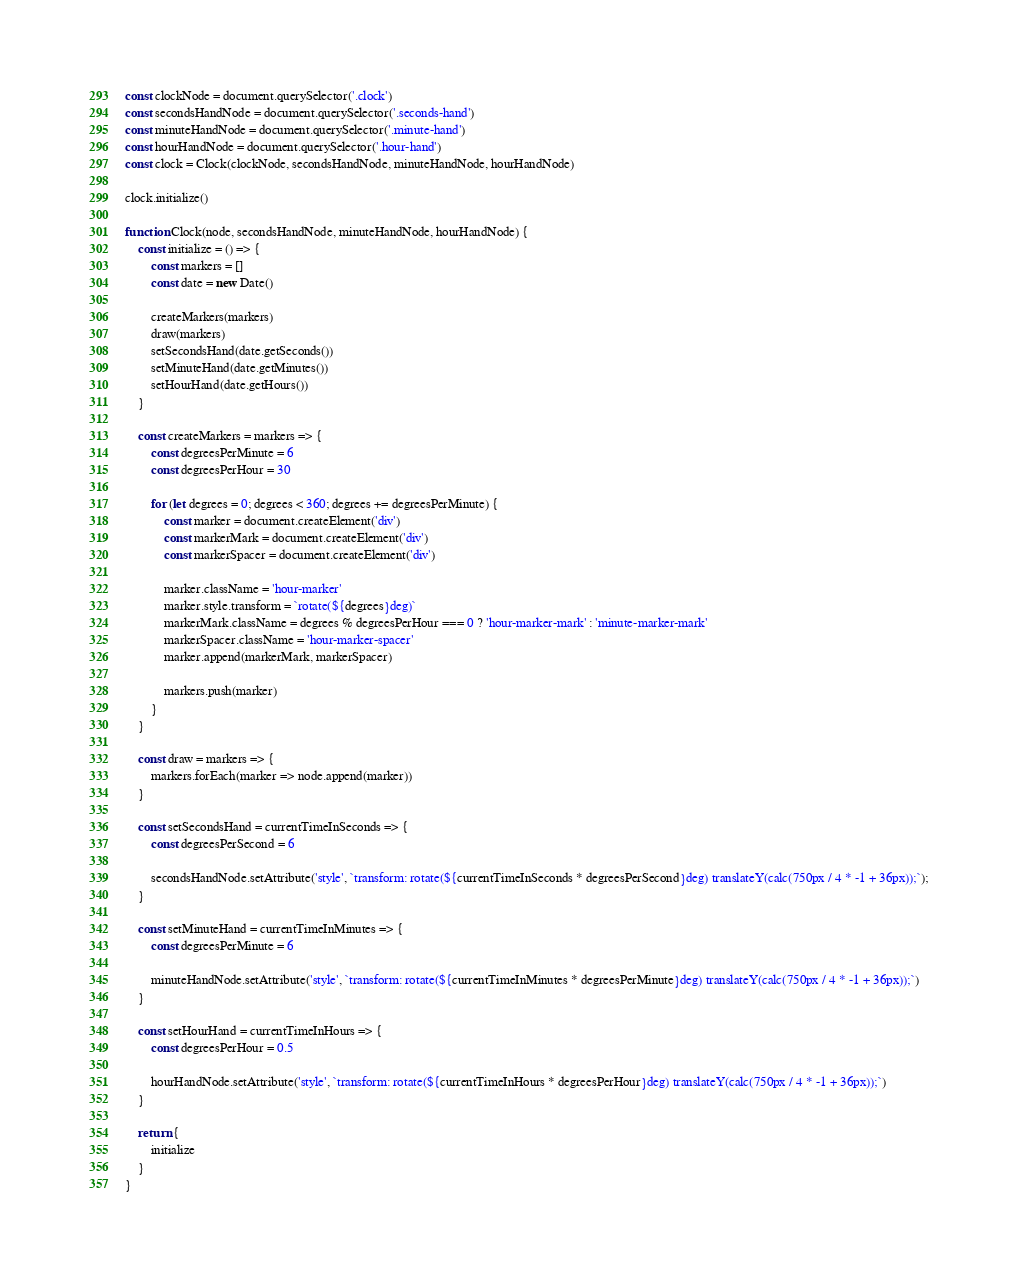<code> <loc_0><loc_0><loc_500><loc_500><_JavaScript_>const clockNode = document.querySelector('.clock')
const secondsHandNode = document.querySelector('.seconds-hand')
const minuteHandNode = document.querySelector('.minute-hand')
const hourHandNode = document.querySelector('.hour-hand')
const clock = Clock(clockNode, secondsHandNode, minuteHandNode, hourHandNode)

clock.initialize()

function Clock(node, secondsHandNode, minuteHandNode, hourHandNode) {
    const initialize = () => {
        const markers = []
        const date = new Date()

        createMarkers(markers)
        draw(markers)
        setSecondsHand(date.getSeconds())
        setMinuteHand(date.getMinutes())
        setHourHand(date.getHours())
    }

    const createMarkers = markers => {
        const degreesPerMinute = 6
        const degreesPerHour = 30

        for (let degrees = 0; degrees < 360; degrees += degreesPerMinute) {
            const marker = document.createElement('div')
            const markerMark = document.createElement('div')
            const markerSpacer = document.createElement('div')

            marker.className = 'hour-marker'
            marker.style.transform = `rotate(${degrees}deg)`
            markerMark.className = degrees % degreesPerHour === 0 ? 'hour-marker-mark' : 'minute-marker-mark'
            markerSpacer.className = 'hour-marker-spacer'
            marker.append(markerMark, markerSpacer)

            markers.push(marker)
        }
    }

    const draw = markers => {
        markers.forEach(marker => node.append(marker))
    }

    const setSecondsHand = currentTimeInSeconds => {
        const degreesPerSecond = 6

        secondsHandNode.setAttribute('style', `transform: rotate(${currentTimeInSeconds * degreesPerSecond}deg) translateY(calc(750px / 4 * -1 + 36px));`);
    }

    const setMinuteHand = currentTimeInMinutes => {
        const degreesPerMinute = 6

        minuteHandNode.setAttribute('style', `transform: rotate(${currentTimeInMinutes * degreesPerMinute}deg) translateY(calc(750px / 4 * -1 + 36px));`)
    }

    const setHourHand = currentTimeInHours => {
        const degreesPerHour = 0.5

        hourHandNode.setAttribute('style', `transform: rotate(${currentTimeInHours * degreesPerHour}deg) translateY(calc(750px / 4 * -1 + 36px));`)
    }

    return {
        initialize
    }
}</code> 